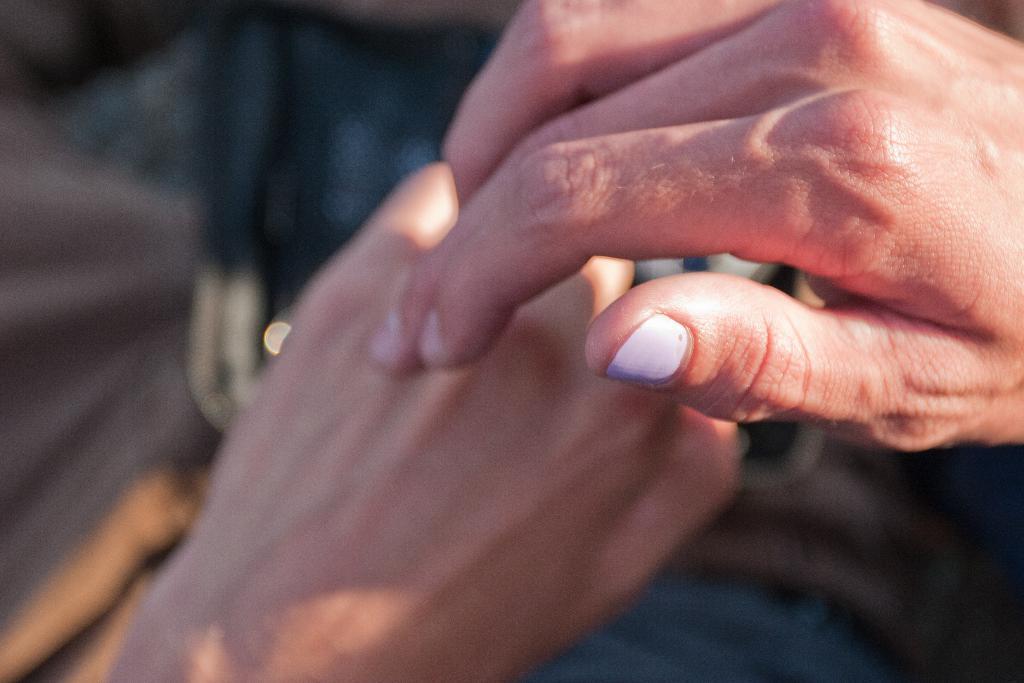Describe this image in one or two sentences. In this image it seems to be the hands of a person. And the background is blurred. 